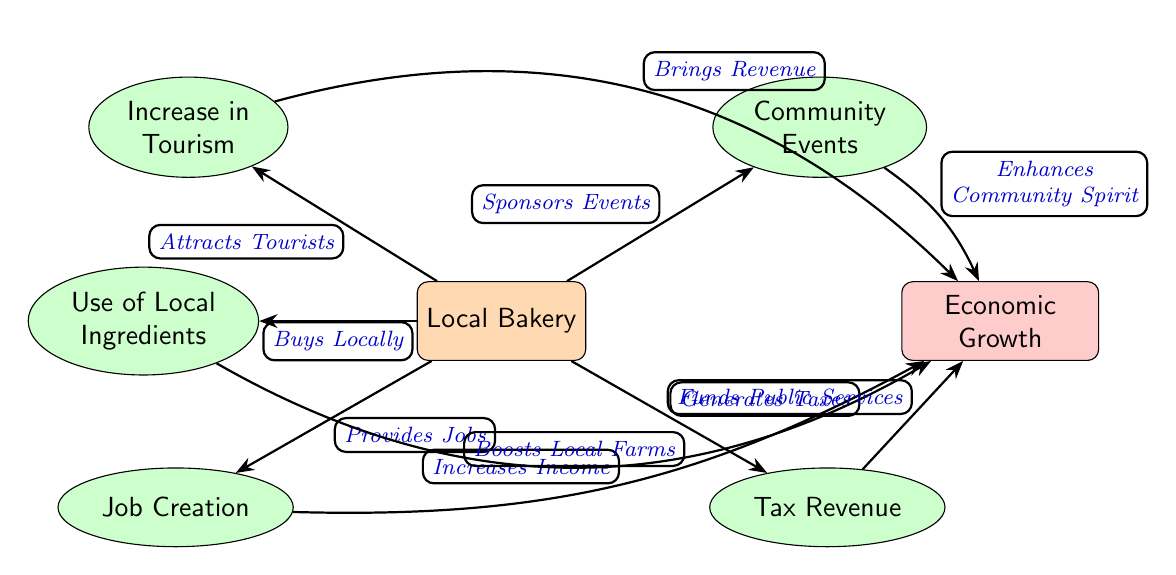What is the central node in the diagram? The central node represents the main subject of the diagram, which is the "Local Bakery".
Answer: Local Bakery How many sub-nodes are connected to the main node? Counting all nodes branching directly from the "Local Bakery", we find there are a total of five sub-nodes.
Answer: 5 What effect does the bakery have on job creation? The connection states that the bakery "Provides Jobs", indicating a direct positive impact on job creation.
Answer: Provides Jobs Which sub-node relates to community events? The sub-node connected specifically to community events is labeled "Community Events".
Answer: Community Events What is the result of the increased tourism? The "Increased Tourism" sub-node has a direct connection to "Economic Growth", indicating that tourism contributes positively to the local economy.
Answer: Economic Growth How does the bakery's use of local ingredients affect local farms? The edge from "Use of Local Ingredients" states that it "Boosts Local Farms", implying the positive effect of sourcing locally.
Answer: Boosts Local Farms What is the relationship between tax revenue and public services? The edge indicates that the tax revenue "Funds Public Services", showcasing how taxes generated by the bakery contribute to community resources.
Answer: Funds Public Services How does increased employment affect overall economic growth? The connection shows that "Job Creation" leads to "Increases Income", which ultimately contributes to "Economic Growth".
Answer: Increases Income What two nodes directly contribute to enhancing community spirit? The nodes "Community Events" and "Increased Tourism" lead to the enhancement of community spirit, combining local engagement and visitor participation.
Answer: Community Events, Increased Tourism 